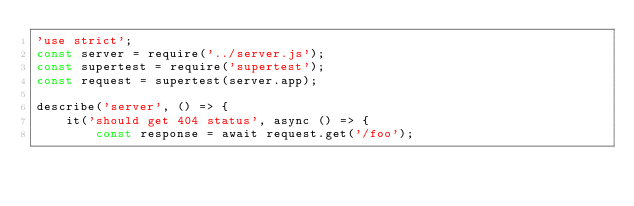Convert code to text. <code><loc_0><loc_0><loc_500><loc_500><_JavaScript_>'use strict';
const server = require('../server.js');
const supertest = require('supertest');
const request = supertest(server.app);

describe('server', () => {
    it('should get 404 status', async () => {
        const response = await request.get('/foo');</code> 